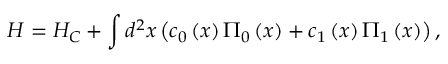<formula> <loc_0><loc_0><loc_500><loc_500>H = H _ { C } + \int { d ^ { 2 } } x \left ( { c _ { 0 } \left ( x \right ) \Pi _ { 0 } \left ( x \right ) + c _ { 1 } \left ( x \right ) \Pi _ { 1 } \left ( x \right ) } \right ) ,</formula> 